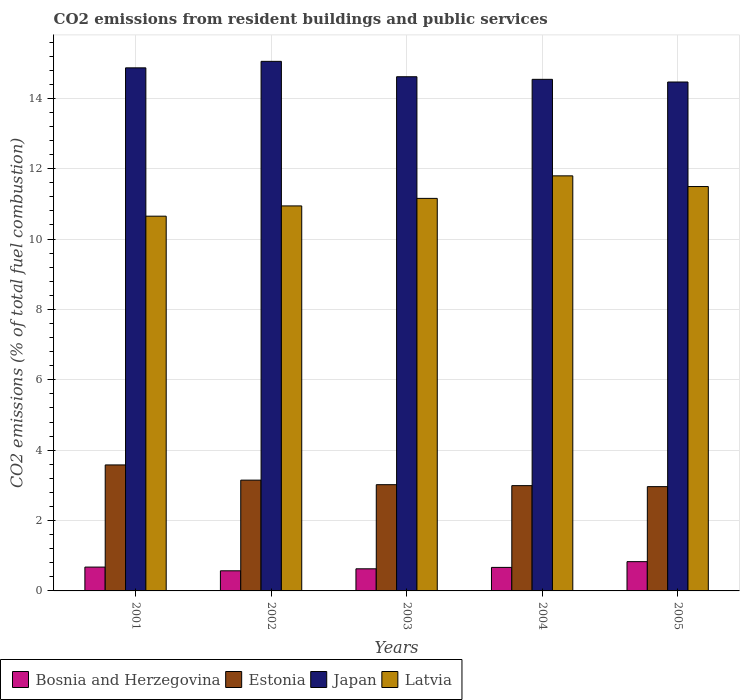How many bars are there on the 2nd tick from the left?
Keep it short and to the point. 4. How many bars are there on the 2nd tick from the right?
Your response must be concise. 4. What is the total CO2 emitted in Estonia in 2001?
Provide a short and direct response. 3.58. Across all years, what is the maximum total CO2 emitted in Bosnia and Herzegovina?
Offer a terse response. 0.83. Across all years, what is the minimum total CO2 emitted in Estonia?
Keep it short and to the point. 2.96. In which year was the total CO2 emitted in Latvia maximum?
Your response must be concise. 2004. In which year was the total CO2 emitted in Latvia minimum?
Your answer should be very brief. 2001. What is the total total CO2 emitted in Estonia in the graph?
Your response must be concise. 15.7. What is the difference between the total CO2 emitted in Latvia in 2001 and that in 2002?
Your answer should be compact. -0.29. What is the difference between the total CO2 emitted in Japan in 2001 and the total CO2 emitted in Latvia in 2002?
Offer a terse response. 3.92. What is the average total CO2 emitted in Estonia per year?
Offer a terse response. 3.14. In the year 2001, what is the difference between the total CO2 emitted in Japan and total CO2 emitted in Bosnia and Herzegovina?
Give a very brief answer. 14.19. In how many years, is the total CO2 emitted in Japan greater than 8?
Your answer should be compact. 5. What is the ratio of the total CO2 emitted in Bosnia and Herzegovina in 2001 to that in 2004?
Make the answer very short. 1.01. What is the difference between the highest and the second highest total CO2 emitted in Estonia?
Give a very brief answer. 0.43. What is the difference between the highest and the lowest total CO2 emitted in Bosnia and Herzegovina?
Make the answer very short. 0.26. Is the sum of the total CO2 emitted in Latvia in 2002 and 2003 greater than the maximum total CO2 emitted in Japan across all years?
Your answer should be very brief. Yes. What does the 3rd bar from the left in 2005 represents?
Give a very brief answer. Japan. What does the 2nd bar from the right in 2005 represents?
Your answer should be very brief. Japan. Is it the case that in every year, the sum of the total CO2 emitted in Bosnia and Herzegovina and total CO2 emitted in Estonia is greater than the total CO2 emitted in Latvia?
Make the answer very short. No. How many bars are there?
Make the answer very short. 20. What is the difference between two consecutive major ticks on the Y-axis?
Your response must be concise. 2. Does the graph contain grids?
Offer a very short reply. Yes. Where does the legend appear in the graph?
Provide a succinct answer. Bottom left. How many legend labels are there?
Keep it short and to the point. 4. What is the title of the graph?
Make the answer very short. CO2 emissions from resident buildings and public services. Does "St. Kitts and Nevis" appear as one of the legend labels in the graph?
Provide a short and direct response. No. What is the label or title of the Y-axis?
Ensure brevity in your answer.  CO2 emissions (% of total fuel combustion). What is the CO2 emissions (% of total fuel combustion) in Bosnia and Herzegovina in 2001?
Make the answer very short. 0.68. What is the CO2 emissions (% of total fuel combustion) in Estonia in 2001?
Your answer should be compact. 3.58. What is the CO2 emissions (% of total fuel combustion) of Japan in 2001?
Offer a terse response. 14.87. What is the CO2 emissions (% of total fuel combustion) in Latvia in 2001?
Your answer should be very brief. 10.65. What is the CO2 emissions (% of total fuel combustion) of Bosnia and Herzegovina in 2002?
Ensure brevity in your answer.  0.57. What is the CO2 emissions (% of total fuel combustion) in Estonia in 2002?
Offer a terse response. 3.15. What is the CO2 emissions (% of total fuel combustion) of Japan in 2002?
Provide a short and direct response. 15.05. What is the CO2 emissions (% of total fuel combustion) in Latvia in 2002?
Keep it short and to the point. 10.94. What is the CO2 emissions (% of total fuel combustion) of Bosnia and Herzegovina in 2003?
Offer a terse response. 0.63. What is the CO2 emissions (% of total fuel combustion) in Estonia in 2003?
Your answer should be compact. 3.02. What is the CO2 emissions (% of total fuel combustion) in Japan in 2003?
Make the answer very short. 14.61. What is the CO2 emissions (% of total fuel combustion) in Latvia in 2003?
Keep it short and to the point. 11.16. What is the CO2 emissions (% of total fuel combustion) in Bosnia and Herzegovina in 2004?
Offer a very short reply. 0.67. What is the CO2 emissions (% of total fuel combustion) of Estonia in 2004?
Give a very brief answer. 2.99. What is the CO2 emissions (% of total fuel combustion) in Japan in 2004?
Your response must be concise. 14.54. What is the CO2 emissions (% of total fuel combustion) in Latvia in 2004?
Your answer should be very brief. 11.8. What is the CO2 emissions (% of total fuel combustion) of Bosnia and Herzegovina in 2005?
Provide a short and direct response. 0.83. What is the CO2 emissions (% of total fuel combustion) in Estonia in 2005?
Your answer should be compact. 2.96. What is the CO2 emissions (% of total fuel combustion) of Japan in 2005?
Make the answer very short. 14.46. What is the CO2 emissions (% of total fuel combustion) in Latvia in 2005?
Your response must be concise. 11.49. Across all years, what is the maximum CO2 emissions (% of total fuel combustion) in Bosnia and Herzegovina?
Provide a short and direct response. 0.83. Across all years, what is the maximum CO2 emissions (% of total fuel combustion) of Estonia?
Your answer should be very brief. 3.58. Across all years, what is the maximum CO2 emissions (% of total fuel combustion) in Japan?
Your response must be concise. 15.05. Across all years, what is the maximum CO2 emissions (% of total fuel combustion) of Latvia?
Your answer should be compact. 11.8. Across all years, what is the minimum CO2 emissions (% of total fuel combustion) of Bosnia and Herzegovina?
Give a very brief answer. 0.57. Across all years, what is the minimum CO2 emissions (% of total fuel combustion) in Estonia?
Provide a succinct answer. 2.96. Across all years, what is the minimum CO2 emissions (% of total fuel combustion) in Japan?
Provide a succinct answer. 14.46. Across all years, what is the minimum CO2 emissions (% of total fuel combustion) of Latvia?
Provide a short and direct response. 10.65. What is the total CO2 emissions (% of total fuel combustion) in Bosnia and Herzegovina in the graph?
Your answer should be very brief. 3.38. What is the total CO2 emissions (% of total fuel combustion) of Estonia in the graph?
Make the answer very short. 15.7. What is the total CO2 emissions (% of total fuel combustion) in Japan in the graph?
Your response must be concise. 73.53. What is the total CO2 emissions (% of total fuel combustion) of Latvia in the graph?
Your answer should be very brief. 56.04. What is the difference between the CO2 emissions (% of total fuel combustion) in Bosnia and Herzegovina in 2001 and that in 2002?
Offer a terse response. 0.11. What is the difference between the CO2 emissions (% of total fuel combustion) of Estonia in 2001 and that in 2002?
Provide a short and direct response. 0.43. What is the difference between the CO2 emissions (% of total fuel combustion) in Japan in 2001 and that in 2002?
Make the answer very short. -0.18. What is the difference between the CO2 emissions (% of total fuel combustion) of Latvia in 2001 and that in 2002?
Ensure brevity in your answer.  -0.29. What is the difference between the CO2 emissions (% of total fuel combustion) in Bosnia and Herzegovina in 2001 and that in 2003?
Ensure brevity in your answer.  0.05. What is the difference between the CO2 emissions (% of total fuel combustion) of Estonia in 2001 and that in 2003?
Provide a short and direct response. 0.56. What is the difference between the CO2 emissions (% of total fuel combustion) of Japan in 2001 and that in 2003?
Ensure brevity in your answer.  0.25. What is the difference between the CO2 emissions (% of total fuel combustion) in Latvia in 2001 and that in 2003?
Make the answer very short. -0.51. What is the difference between the CO2 emissions (% of total fuel combustion) of Bosnia and Herzegovina in 2001 and that in 2004?
Make the answer very short. 0.01. What is the difference between the CO2 emissions (% of total fuel combustion) in Estonia in 2001 and that in 2004?
Make the answer very short. 0.59. What is the difference between the CO2 emissions (% of total fuel combustion) in Japan in 2001 and that in 2004?
Give a very brief answer. 0.33. What is the difference between the CO2 emissions (% of total fuel combustion) in Latvia in 2001 and that in 2004?
Offer a very short reply. -1.15. What is the difference between the CO2 emissions (% of total fuel combustion) of Bosnia and Herzegovina in 2001 and that in 2005?
Make the answer very short. -0.15. What is the difference between the CO2 emissions (% of total fuel combustion) of Estonia in 2001 and that in 2005?
Your answer should be compact. 0.62. What is the difference between the CO2 emissions (% of total fuel combustion) in Japan in 2001 and that in 2005?
Make the answer very short. 0.4. What is the difference between the CO2 emissions (% of total fuel combustion) in Latvia in 2001 and that in 2005?
Give a very brief answer. -0.84. What is the difference between the CO2 emissions (% of total fuel combustion) of Bosnia and Herzegovina in 2002 and that in 2003?
Your response must be concise. -0.06. What is the difference between the CO2 emissions (% of total fuel combustion) in Estonia in 2002 and that in 2003?
Offer a terse response. 0.13. What is the difference between the CO2 emissions (% of total fuel combustion) of Japan in 2002 and that in 2003?
Provide a short and direct response. 0.44. What is the difference between the CO2 emissions (% of total fuel combustion) of Latvia in 2002 and that in 2003?
Give a very brief answer. -0.21. What is the difference between the CO2 emissions (% of total fuel combustion) in Bosnia and Herzegovina in 2002 and that in 2004?
Your response must be concise. -0.1. What is the difference between the CO2 emissions (% of total fuel combustion) in Estonia in 2002 and that in 2004?
Provide a succinct answer. 0.16. What is the difference between the CO2 emissions (% of total fuel combustion) in Japan in 2002 and that in 2004?
Keep it short and to the point. 0.51. What is the difference between the CO2 emissions (% of total fuel combustion) in Latvia in 2002 and that in 2004?
Your answer should be compact. -0.85. What is the difference between the CO2 emissions (% of total fuel combustion) of Bosnia and Herzegovina in 2002 and that in 2005?
Provide a short and direct response. -0.26. What is the difference between the CO2 emissions (% of total fuel combustion) in Estonia in 2002 and that in 2005?
Offer a very short reply. 0.18. What is the difference between the CO2 emissions (% of total fuel combustion) of Japan in 2002 and that in 2005?
Ensure brevity in your answer.  0.59. What is the difference between the CO2 emissions (% of total fuel combustion) of Latvia in 2002 and that in 2005?
Your answer should be very brief. -0.55. What is the difference between the CO2 emissions (% of total fuel combustion) of Bosnia and Herzegovina in 2003 and that in 2004?
Provide a short and direct response. -0.04. What is the difference between the CO2 emissions (% of total fuel combustion) of Estonia in 2003 and that in 2004?
Provide a short and direct response. 0.03. What is the difference between the CO2 emissions (% of total fuel combustion) in Japan in 2003 and that in 2004?
Your answer should be compact. 0.07. What is the difference between the CO2 emissions (% of total fuel combustion) in Latvia in 2003 and that in 2004?
Provide a succinct answer. -0.64. What is the difference between the CO2 emissions (% of total fuel combustion) in Bosnia and Herzegovina in 2003 and that in 2005?
Provide a succinct answer. -0.2. What is the difference between the CO2 emissions (% of total fuel combustion) of Estonia in 2003 and that in 2005?
Your response must be concise. 0.06. What is the difference between the CO2 emissions (% of total fuel combustion) in Japan in 2003 and that in 2005?
Offer a very short reply. 0.15. What is the difference between the CO2 emissions (% of total fuel combustion) in Latvia in 2003 and that in 2005?
Your answer should be compact. -0.34. What is the difference between the CO2 emissions (% of total fuel combustion) in Bosnia and Herzegovina in 2004 and that in 2005?
Ensure brevity in your answer.  -0.16. What is the difference between the CO2 emissions (% of total fuel combustion) of Estonia in 2004 and that in 2005?
Make the answer very short. 0.03. What is the difference between the CO2 emissions (% of total fuel combustion) in Japan in 2004 and that in 2005?
Provide a succinct answer. 0.08. What is the difference between the CO2 emissions (% of total fuel combustion) in Latvia in 2004 and that in 2005?
Your answer should be very brief. 0.3. What is the difference between the CO2 emissions (% of total fuel combustion) of Bosnia and Herzegovina in 2001 and the CO2 emissions (% of total fuel combustion) of Estonia in 2002?
Your answer should be compact. -2.47. What is the difference between the CO2 emissions (% of total fuel combustion) of Bosnia and Herzegovina in 2001 and the CO2 emissions (% of total fuel combustion) of Japan in 2002?
Provide a short and direct response. -14.37. What is the difference between the CO2 emissions (% of total fuel combustion) in Bosnia and Herzegovina in 2001 and the CO2 emissions (% of total fuel combustion) in Latvia in 2002?
Offer a very short reply. -10.26. What is the difference between the CO2 emissions (% of total fuel combustion) of Estonia in 2001 and the CO2 emissions (% of total fuel combustion) of Japan in 2002?
Your answer should be compact. -11.47. What is the difference between the CO2 emissions (% of total fuel combustion) of Estonia in 2001 and the CO2 emissions (% of total fuel combustion) of Latvia in 2002?
Keep it short and to the point. -7.36. What is the difference between the CO2 emissions (% of total fuel combustion) of Japan in 2001 and the CO2 emissions (% of total fuel combustion) of Latvia in 2002?
Make the answer very short. 3.92. What is the difference between the CO2 emissions (% of total fuel combustion) of Bosnia and Herzegovina in 2001 and the CO2 emissions (% of total fuel combustion) of Estonia in 2003?
Keep it short and to the point. -2.34. What is the difference between the CO2 emissions (% of total fuel combustion) of Bosnia and Herzegovina in 2001 and the CO2 emissions (% of total fuel combustion) of Japan in 2003?
Make the answer very short. -13.94. What is the difference between the CO2 emissions (% of total fuel combustion) of Bosnia and Herzegovina in 2001 and the CO2 emissions (% of total fuel combustion) of Latvia in 2003?
Make the answer very short. -10.48. What is the difference between the CO2 emissions (% of total fuel combustion) of Estonia in 2001 and the CO2 emissions (% of total fuel combustion) of Japan in 2003?
Offer a terse response. -11.03. What is the difference between the CO2 emissions (% of total fuel combustion) in Estonia in 2001 and the CO2 emissions (% of total fuel combustion) in Latvia in 2003?
Provide a succinct answer. -7.58. What is the difference between the CO2 emissions (% of total fuel combustion) of Japan in 2001 and the CO2 emissions (% of total fuel combustion) of Latvia in 2003?
Offer a very short reply. 3.71. What is the difference between the CO2 emissions (% of total fuel combustion) in Bosnia and Herzegovina in 2001 and the CO2 emissions (% of total fuel combustion) in Estonia in 2004?
Your answer should be very brief. -2.31. What is the difference between the CO2 emissions (% of total fuel combustion) in Bosnia and Herzegovina in 2001 and the CO2 emissions (% of total fuel combustion) in Japan in 2004?
Provide a succinct answer. -13.86. What is the difference between the CO2 emissions (% of total fuel combustion) in Bosnia and Herzegovina in 2001 and the CO2 emissions (% of total fuel combustion) in Latvia in 2004?
Make the answer very short. -11.12. What is the difference between the CO2 emissions (% of total fuel combustion) of Estonia in 2001 and the CO2 emissions (% of total fuel combustion) of Japan in 2004?
Ensure brevity in your answer.  -10.96. What is the difference between the CO2 emissions (% of total fuel combustion) in Estonia in 2001 and the CO2 emissions (% of total fuel combustion) in Latvia in 2004?
Your answer should be compact. -8.22. What is the difference between the CO2 emissions (% of total fuel combustion) in Japan in 2001 and the CO2 emissions (% of total fuel combustion) in Latvia in 2004?
Offer a terse response. 3.07. What is the difference between the CO2 emissions (% of total fuel combustion) of Bosnia and Herzegovina in 2001 and the CO2 emissions (% of total fuel combustion) of Estonia in 2005?
Give a very brief answer. -2.29. What is the difference between the CO2 emissions (% of total fuel combustion) in Bosnia and Herzegovina in 2001 and the CO2 emissions (% of total fuel combustion) in Japan in 2005?
Make the answer very short. -13.79. What is the difference between the CO2 emissions (% of total fuel combustion) in Bosnia and Herzegovina in 2001 and the CO2 emissions (% of total fuel combustion) in Latvia in 2005?
Keep it short and to the point. -10.82. What is the difference between the CO2 emissions (% of total fuel combustion) in Estonia in 2001 and the CO2 emissions (% of total fuel combustion) in Japan in 2005?
Ensure brevity in your answer.  -10.88. What is the difference between the CO2 emissions (% of total fuel combustion) of Estonia in 2001 and the CO2 emissions (% of total fuel combustion) of Latvia in 2005?
Make the answer very short. -7.91. What is the difference between the CO2 emissions (% of total fuel combustion) of Japan in 2001 and the CO2 emissions (% of total fuel combustion) of Latvia in 2005?
Your answer should be very brief. 3.37. What is the difference between the CO2 emissions (% of total fuel combustion) of Bosnia and Herzegovina in 2002 and the CO2 emissions (% of total fuel combustion) of Estonia in 2003?
Your answer should be compact. -2.45. What is the difference between the CO2 emissions (% of total fuel combustion) of Bosnia and Herzegovina in 2002 and the CO2 emissions (% of total fuel combustion) of Japan in 2003?
Keep it short and to the point. -14.04. What is the difference between the CO2 emissions (% of total fuel combustion) in Bosnia and Herzegovina in 2002 and the CO2 emissions (% of total fuel combustion) in Latvia in 2003?
Provide a succinct answer. -10.58. What is the difference between the CO2 emissions (% of total fuel combustion) in Estonia in 2002 and the CO2 emissions (% of total fuel combustion) in Japan in 2003?
Ensure brevity in your answer.  -11.46. What is the difference between the CO2 emissions (% of total fuel combustion) of Estonia in 2002 and the CO2 emissions (% of total fuel combustion) of Latvia in 2003?
Provide a short and direct response. -8.01. What is the difference between the CO2 emissions (% of total fuel combustion) in Japan in 2002 and the CO2 emissions (% of total fuel combustion) in Latvia in 2003?
Give a very brief answer. 3.89. What is the difference between the CO2 emissions (% of total fuel combustion) of Bosnia and Herzegovina in 2002 and the CO2 emissions (% of total fuel combustion) of Estonia in 2004?
Offer a very short reply. -2.42. What is the difference between the CO2 emissions (% of total fuel combustion) in Bosnia and Herzegovina in 2002 and the CO2 emissions (% of total fuel combustion) in Japan in 2004?
Your answer should be compact. -13.97. What is the difference between the CO2 emissions (% of total fuel combustion) in Bosnia and Herzegovina in 2002 and the CO2 emissions (% of total fuel combustion) in Latvia in 2004?
Ensure brevity in your answer.  -11.22. What is the difference between the CO2 emissions (% of total fuel combustion) of Estonia in 2002 and the CO2 emissions (% of total fuel combustion) of Japan in 2004?
Provide a short and direct response. -11.39. What is the difference between the CO2 emissions (% of total fuel combustion) of Estonia in 2002 and the CO2 emissions (% of total fuel combustion) of Latvia in 2004?
Make the answer very short. -8.65. What is the difference between the CO2 emissions (% of total fuel combustion) of Japan in 2002 and the CO2 emissions (% of total fuel combustion) of Latvia in 2004?
Ensure brevity in your answer.  3.25. What is the difference between the CO2 emissions (% of total fuel combustion) of Bosnia and Herzegovina in 2002 and the CO2 emissions (% of total fuel combustion) of Estonia in 2005?
Offer a terse response. -2.39. What is the difference between the CO2 emissions (% of total fuel combustion) of Bosnia and Herzegovina in 2002 and the CO2 emissions (% of total fuel combustion) of Japan in 2005?
Give a very brief answer. -13.89. What is the difference between the CO2 emissions (% of total fuel combustion) of Bosnia and Herzegovina in 2002 and the CO2 emissions (% of total fuel combustion) of Latvia in 2005?
Provide a succinct answer. -10.92. What is the difference between the CO2 emissions (% of total fuel combustion) of Estonia in 2002 and the CO2 emissions (% of total fuel combustion) of Japan in 2005?
Provide a short and direct response. -11.31. What is the difference between the CO2 emissions (% of total fuel combustion) in Estonia in 2002 and the CO2 emissions (% of total fuel combustion) in Latvia in 2005?
Give a very brief answer. -8.34. What is the difference between the CO2 emissions (% of total fuel combustion) of Japan in 2002 and the CO2 emissions (% of total fuel combustion) of Latvia in 2005?
Your answer should be very brief. 3.56. What is the difference between the CO2 emissions (% of total fuel combustion) in Bosnia and Herzegovina in 2003 and the CO2 emissions (% of total fuel combustion) in Estonia in 2004?
Make the answer very short. -2.36. What is the difference between the CO2 emissions (% of total fuel combustion) in Bosnia and Herzegovina in 2003 and the CO2 emissions (% of total fuel combustion) in Japan in 2004?
Your response must be concise. -13.91. What is the difference between the CO2 emissions (% of total fuel combustion) in Bosnia and Herzegovina in 2003 and the CO2 emissions (% of total fuel combustion) in Latvia in 2004?
Your response must be concise. -11.17. What is the difference between the CO2 emissions (% of total fuel combustion) of Estonia in 2003 and the CO2 emissions (% of total fuel combustion) of Japan in 2004?
Your answer should be compact. -11.52. What is the difference between the CO2 emissions (% of total fuel combustion) of Estonia in 2003 and the CO2 emissions (% of total fuel combustion) of Latvia in 2004?
Your answer should be compact. -8.78. What is the difference between the CO2 emissions (% of total fuel combustion) in Japan in 2003 and the CO2 emissions (% of total fuel combustion) in Latvia in 2004?
Ensure brevity in your answer.  2.82. What is the difference between the CO2 emissions (% of total fuel combustion) of Bosnia and Herzegovina in 2003 and the CO2 emissions (% of total fuel combustion) of Estonia in 2005?
Give a very brief answer. -2.34. What is the difference between the CO2 emissions (% of total fuel combustion) of Bosnia and Herzegovina in 2003 and the CO2 emissions (% of total fuel combustion) of Japan in 2005?
Provide a succinct answer. -13.83. What is the difference between the CO2 emissions (% of total fuel combustion) in Bosnia and Herzegovina in 2003 and the CO2 emissions (% of total fuel combustion) in Latvia in 2005?
Ensure brevity in your answer.  -10.86. What is the difference between the CO2 emissions (% of total fuel combustion) of Estonia in 2003 and the CO2 emissions (% of total fuel combustion) of Japan in 2005?
Provide a short and direct response. -11.44. What is the difference between the CO2 emissions (% of total fuel combustion) in Estonia in 2003 and the CO2 emissions (% of total fuel combustion) in Latvia in 2005?
Offer a very short reply. -8.47. What is the difference between the CO2 emissions (% of total fuel combustion) of Japan in 2003 and the CO2 emissions (% of total fuel combustion) of Latvia in 2005?
Your answer should be very brief. 3.12. What is the difference between the CO2 emissions (% of total fuel combustion) in Bosnia and Herzegovina in 2004 and the CO2 emissions (% of total fuel combustion) in Estonia in 2005?
Your response must be concise. -2.3. What is the difference between the CO2 emissions (% of total fuel combustion) in Bosnia and Herzegovina in 2004 and the CO2 emissions (% of total fuel combustion) in Japan in 2005?
Your answer should be compact. -13.79. What is the difference between the CO2 emissions (% of total fuel combustion) in Bosnia and Herzegovina in 2004 and the CO2 emissions (% of total fuel combustion) in Latvia in 2005?
Provide a short and direct response. -10.82. What is the difference between the CO2 emissions (% of total fuel combustion) of Estonia in 2004 and the CO2 emissions (% of total fuel combustion) of Japan in 2005?
Keep it short and to the point. -11.47. What is the difference between the CO2 emissions (% of total fuel combustion) in Estonia in 2004 and the CO2 emissions (% of total fuel combustion) in Latvia in 2005?
Your answer should be very brief. -8.5. What is the difference between the CO2 emissions (% of total fuel combustion) in Japan in 2004 and the CO2 emissions (% of total fuel combustion) in Latvia in 2005?
Provide a succinct answer. 3.05. What is the average CO2 emissions (% of total fuel combustion) of Bosnia and Herzegovina per year?
Give a very brief answer. 0.68. What is the average CO2 emissions (% of total fuel combustion) of Estonia per year?
Offer a very short reply. 3.14. What is the average CO2 emissions (% of total fuel combustion) of Japan per year?
Provide a succinct answer. 14.71. What is the average CO2 emissions (% of total fuel combustion) in Latvia per year?
Keep it short and to the point. 11.21. In the year 2001, what is the difference between the CO2 emissions (% of total fuel combustion) of Bosnia and Herzegovina and CO2 emissions (% of total fuel combustion) of Estonia?
Provide a short and direct response. -2.9. In the year 2001, what is the difference between the CO2 emissions (% of total fuel combustion) of Bosnia and Herzegovina and CO2 emissions (% of total fuel combustion) of Japan?
Offer a very short reply. -14.19. In the year 2001, what is the difference between the CO2 emissions (% of total fuel combustion) of Bosnia and Herzegovina and CO2 emissions (% of total fuel combustion) of Latvia?
Your answer should be very brief. -9.97. In the year 2001, what is the difference between the CO2 emissions (% of total fuel combustion) in Estonia and CO2 emissions (% of total fuel combustion) in Japan?
Provide a succinct answer. -11.28. In the year 2001, what is the difference between the CO2 emissions (% of total fuel combustion) in Estonia and CO2 emissions (% of total fuel combustion) in Latvia?
Your response must be concise. -7.07. In the year 2001, what is the difference between the CO2 emissions (% of total fuel combustion) of Japan and CO2 emissions (% of total fuel combustion) of Latvia?
Your answer should be compact. 4.22. In the year 2002, what is the difference between the CO2 emissions (% of total fuel combustion) in Bosnia and Herzegovina and CO2 emissions (% of total fuel combustion) in Estonia?
Give a very brief answer. -2.58. In the year 2002, what is the difference between the CO2 emissions (% of total fuel combustion) of Bosnia and Herzegovina and CO2 emissions (% of total fuel combustion) of Japan?
Your answer should be very brief. -14.48. In the year 2002, what is the difference between the CO2 emissions (% of total fuel combustion) of Bosnia and Herzegovina and CO2 emissions (% of total fuel combustion) of Latvia?
Ensure brevity in your answer.  -10.37. In the year 2002, what is the difference between the CO2 emissions (% of total fuel combustion) in Estonia and CO2 emissions (% of total fuel combustion) in Japan?
Ensure brevity in your answer.  -11.9. In the year 2002, what is the difference between the CO2 emissions (% of total fuel combustion) of Estonia and CO2 emissions (% of total fuel combustion) of Latvia?
Give a very brief answer. -7.79. In the year 2002, what is the difference between the CO2 emissions (% of total fuel combustion) of Japan and CO2 emissions (% of total fuel combustion) of Latvia?
Your answer should be compact. 4.11. In the year 2003, what is the difference between the CO2 emissions (% of total fuel combustion) of Bosnia and Herzegovina and CO2 emissions (% of total fuel combustion) of Estonia?
Your answer should be compact. -2.39. In the year 2003, what is the difference between the CO2 emissions (% of total fuel combustion) in Bosnia and Herzegovina and CO2 emissions (% of total fuel combustion) in Japan?
Ensure brevity in your answer.  -13.98. In the year 2003, what is the difference between the CO2 emissions (% of total fuel combustion) of Bosnia and Herzegovina and CO2 emissions (% of total fuel combustion) of Latvia?
Your answer should be compact. -10.53. In the year 2003, what is the difference between the CO2 emissions (% of total fuel combustion) of Estonia and CO2 emissions (% of total fuel combustion) of Japan?
Your answer should be compact. -11.59. In the year 2003, what is the difference between the CO2 emissions (% of total fuel combustion) of Estonia and CO2 emissions (% of total fuel combustion) of Latvia?
Your response must be concise. -8.14. In the year 2003, what is the difference between the CO2 emissions (% of total fuel combustion) of Japan and CO2 emissions (% of total fuel combustion) of Latvia?
Your answer should be very brief. 3.46. In the year 2004, what is the difference between the CO2 emissions (% of total fuel combustion) of Bosnia and Herzegovina and CO2 emissions (% of total fuel combustion) of Estonia?
Your response must be concise. -2.32. In the year 2004, what is the difference between the CO2 emissions (% of total fuel combustion) of Bosnia and Herzegovina and CO2 emissions (% of total fuel combustion) of Japan?
Offer a terse response. -13.87. In the year 2004, what is the difference between the CO2 emissions (% of total fuel combustion) in Bosnia and Herzegovina and CO2 emissions (% of total fuel combustion) in Latvia?
Your answer should be compact. -11.13. In the year 2004, what is the difference between the CO2 emissions (% of total fuel combustion) of Estonia and CO2 emissions (% of total fuel combustion) of Japan?
Keep it short and to the point. -11.55. In the year 2004, what is the difference between the CO2 emissions (% of total fuel combustion) in Estonia and CO2 emissions (% of total fuel combustion) in Latvia?
Offer a terse response. -8.8. In the year 2004, what is the difference between the CO2 emissions (% of total fuel combustion) in Japan and CO2 emissions (% of total fuel combustion) in Latvia?
Make the answer very short. 2.74. In the year 2005, what is the difference between the CO2 emissions (% of total fuel combustion) in Bosnia and Herzegovina and CO2 emissions (% of total fuel combustion) in Estonia?
Make the answer very short. -2.13. In the year 2005, what is the difference between the CO2 emissions (% of total fuel combustion) in Bosnia and Herzegovina and CO2 emissions (% of total fuel combustion) in Japan?
Your answer should be compact. -13.63. In the year 2005, what is the difference between the CO2 emissions (% of total fuel combustion) in Bosnia and Herzegovina and CO2 emissions (% of total fuel combustion) in Latvia?
Ensure brevity in your answer.  -10.66. In the year 2005, what is the difference between the CO2 emissions (% of total fuel combustion) in Estonia and CO2 emissions (% of total fuel combustion) in Japan?
Ensure brevity in your answer.  -11.5. In the year 2005, what is the difference between the CO2 emissions (% of total fuel combustion) in Estonia and CO2 emissions (% of total fuel combustion) in Latvia?
Provide a short and direct response. -8.53. In the year 2005, what is the difference between the CO2 emissions (% of total fuel combustion) in Japan and CO2 emissions (% of total fuel combustion) in Latvia?
Offer a very short reply. 2.97. What is the ratio of the CO2 emissions (% of total fuel combustion) of Bosnia and Herzegovina in 2001 to that in 2002?
Give a very brief answer. 1.18. What is the ratio of the CO2 emissions (% of total fuel combustion) in Estonia in 2001 to that in 2002?
Offer a terse response. 1.14. What is the ratio of the CO2 emissions (% of total fuel combustion) in Japan in 2001 to that in 2002?
Keep it short and to the point. 0.99. What is the ratio of the CO2 emissions (% of total fuel combustion) of Latvia in 2001 to that in 2002?
Ensure brevity in your answer.  0.97. What is the ratio of the CO2 emissions (% of total fuel combustion) of Bosnia and Herzegovina in 2001 to that in 2003?
Offer a terse response. 1.08. What is the ratio of the CO2 emissions (% of total fuel combustion) in Estonia in 2001 to that in 2003?
Make the answer very short. 1.19. What is the ratio of the CO2 emissions (% of total fuel combustion) of Japan in 2001 to that in 2003?
Your answer should be compact. 1.02. What is the ratio of the CO2 emissions (% of total fuel combustion) of Latvia in 2001 to that in 2003?
Offer a terse response. 0.95. What is the ratio of the CO2 emissions (% of total fuel combustion) in Bosnia and Herzegovina in 2001 to that in 2004?
Provide a succinct answer. 1.01. What is the ratio of the CO2 emissions (% of total fuel combustion) of Estonia in 2001 to that in 2004?
Keep it short and to the point. 1.2. What is the ratio of the CO2 emissions (% of total fuel combustion) in Japan in 2001 to that in 2004?
Provide a short and direct response. 1.02. What is the ratio of the CO2 emissions (% of total fuel combustion) of Latvia in 2001 to that in 2004?
Give a very brief answer. 0.9. What is the ratio of the CO2 emissions (% of total fuel combustion) in Bosnia and Herzegovina in 2001 to that in 2005?
Provide a succinct answer. 0.81. What is the ratio of the CO2 emissions (% of total fuel combustion) in Estonia in 2001 to that in 2005?
Offer a terse response. 1.21. What is the ratio of the CO2 emissions (% of total fuel combustion) in Japan in 2001 to that in 2005?
Your answer should be compact. 1.03. What is the ratio of the CO2 emissions (% of total fuel combustion) of Latvia in 2001 to that in 2005?
Provide a short and direct response. 0.93. What is the ratio of the CO2 emissions (% of total fuel combustion) of Bosnia and Herzegovina in 2002 to that in 2003?
Offer a very short reply. 0.91. What is the ratio of the CO2 emissions (% of total fuel combustion) of Estonia in 2002 to that in 2003?
Offer a very short reply. 1.04. What is the ratio of the CO2 emissions (% of total fuel combustion) in Japan in 2002 to that in 2003?
Your response must be concise. 1.03. What is the ratio of the CO2 emissions (% of total fuel combustion) in Latvia in 2002 to that in 2003?
Your response must be concise. 0.98. What is the ratio of the CO2 emissions (% of total fuel combustion) of Bosnia and Herzegovina in 2002 to that in 2004?
Your answer should be very brief. 0.86. What is the ratio of the CO2 emissions (% of total fuel combustion) in Estonia in 2002 to that in 2004?
Your answer should be very brief. 1.05. What is the ratio of the CO2 emissions (% of total fuel combustion) in Japan in 2002 to that in 2004?
Your answer should be compact. 1.04. What is the ratio of the CO2 emissions (% of total fuel combustion) of Latvia in 2002 to that in 2004?
Your answer should be compact. 0.93. What is the ratio of the CO2 emissions (% of total fuel combustion) of Bosnia and Herzegovina in 2002 to that in 2005?
Keep it short and to the point. 0.69. What is the ratio of the CO2 emissions (% of total fuel combustion) of Estonia in 2002 to that in 2005?
Provide a short and direct response. 1.06. What is the ratio of the CO2 emissions (% of total fuel combustion) in Japan in 2002 to that in 2005?
Offer a terse response. 1.04. What is the ratio of the CO2 emissions (% of total fuel combustion) in Latvia in 2002 to that in 2005?
Your answer should be compact. 0.95. What is the ratio of the CO2 emissions (% of total fuel combustion) in Bosnia and Herzegovina in 2003 to that in 2004?
Give a very brief answer. 0.94. What is the ratio of the CO2 emissions (% of total fuel combustion) in Estonia in 2003 to that in 2004?
Your answer should be compact. 1.01. What is the ratio of the CO2 emissions (% of total fuel combustion) of Latvia in 2003 to that in 2004?
Your answer should be compact. 0.95. What is the ratio of the CO2 emissions (% of total fuel combustion) of Bosnia and Herzegovina in 2003 to that in 2005?
Give a very brief answer. 0.76. What is the ratio of the CO2 emissions (% of total fuel combustion) in Estonia in 2003 to that in 2005?
Provide a succinct answer. 1.02. What is the ratio of the CO2 emissions (% of total fuel combustion) of Japan in 2003 to that in 2005?
Provide a succinct answer. 1.01. What is the ratio of the CO2 emissions (% of total fuel combustion) in Latvia in 2003 to that in 2005?
Offer a terse response. 0.97. What is the ratio of the CO2 emissions (% of total fuel combustion) in Bosnia and Herzegovina in 2004 to that in 2005?
Offer a terse response. 0.8. What is the ratio of the CO2 emissions (% of total fuel combustion) in Estonia in 2004 to that in 2005?
Give a very brief answer. 1.01. What is the ratio of the CO2 emissions (% of total fuel combustion) in Japan in 2004 to that in 2005?
Offer a very short reply. 1.01. What is the ratio of the CO2 emissions (% of total fuel combustion) of Latvia in 2004 to that in 2005?
Ensure brevity in your answer.  1.03. What is the difference between the highest and the second highest CO2 emissions (% of total fuel combustion) in Bosnia and Herzegovina?
Your answer should be compact. 0.15. What is the difference between the highest and the second highest CO2 emissions (% of total fuel combustion) of Estonia?
Keep it short and to the point. 0.43. What is the difference between the highest and the second highest CO2 emissions (% of total fuel combustion) of Japan?
Your answer should be very brief. 0.18. What is the difference between the highest and the second highest CO2 emissions (% of total fuel combustion) in Latvia?
Give a very brief answer. 0.3. What is the difference between the highest and the lowest CO2 emissions (% of total fuel combustion) of Bosnia and Herzegovina?
Give a very brief answer. 0.26. What is the difference between the highest and the lowest CO2 emissions (% of total fuel combustion) of Estonia?
Give a very brief answer. 0.62. What is the difference between the highest and the lowest CO2 emissions (% of total fuel combustion) of Japan?
Offer a terse response. 0.59. What is the difference between the highest and the lowest CO2 emissions (% of total fuel combustion) in Latvia?
Keep it short and to the point. 1.15. 